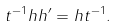<formula> <loc_0><loc_0><loc_500><loc_500>t ^ { - 1 } h h ^ { \prime } = h t ^ { - 1 } .</formula> 